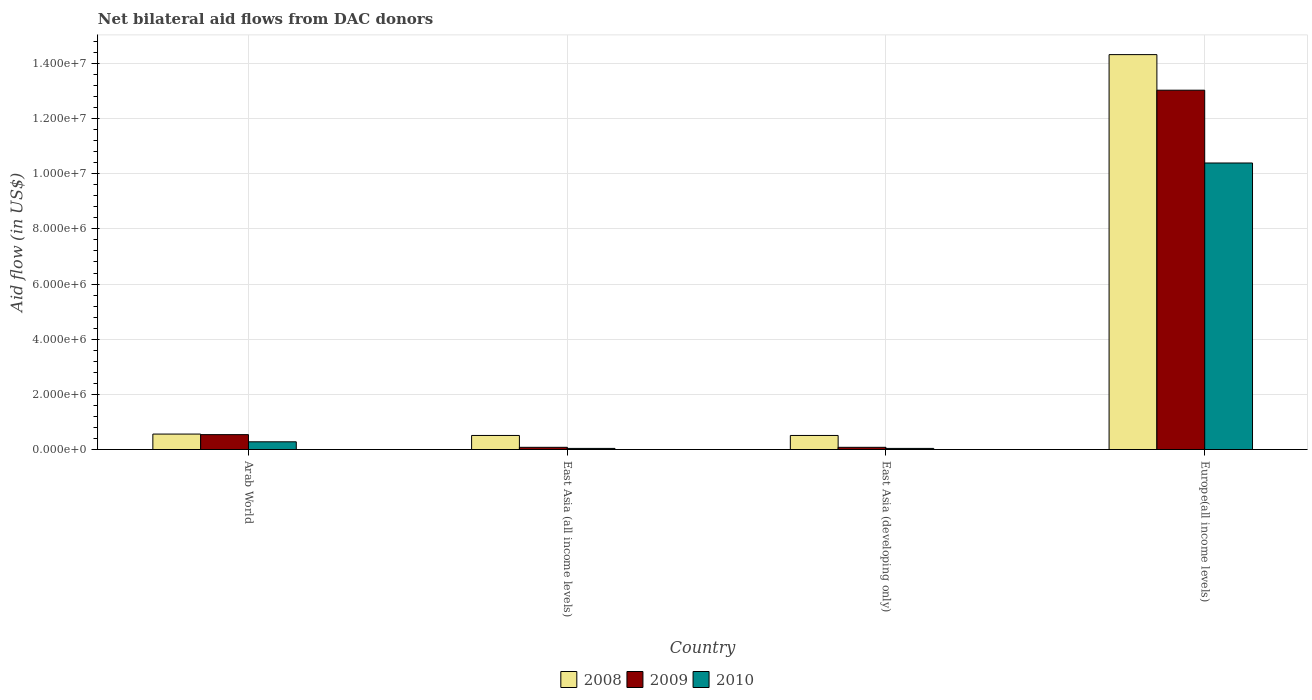How many different coloured bars are there?
Offer a terse response. 3. How many groups of bars are there?
Give a very brief answer. 4. Are the number of bars on each tick of the X-axis equal?
Your answer should be compact. Yes. How many bars are there on the 3rd tick from the left?
Give a very brief answer. 3. How many bars are there on the 3rd tick from the right?
Give a very brief answer. 3. What is the label of the 3rd group of bars from the left?
Ensure brevity in your answer.  East Asia (developing only). What is the net bilateral aid flow in 2009 in Europe(all income levels)?
Offer a terse response. 1.30e+07. Across all countries, what is the maximum net bilateral aid flow in 2009?
Give a very brief answer. 1.30e+07. Across all countries, what is the minimum net bilateral aid flow in 2009?
Provide a succinct answer. 8.00e+04. In which country was the net bilateral aid flow in 2009 maximum?
Your answer should be very brief. Europe(all income levels). In which country was the net bilateral aid flow in 2009 minimum?
Your answer should be compact. East Asia (all income levels). What is the total net bilateral aid flow in 2009 in the graph?
Provide a short and direct response. 1.37e+07. What is the difference between the net bilateral aid flow in 2010 in East Asia (all income levels) and that in Europe(all income levels)?
Give a very brief answer. -1.04e+07. What is the difference between the net bilateral aid flow in 2010 in Europe(all income levels) and the net bilateral aid flow in 2008 in East Asia (developing only)?
Your answer should be compact. 9.88e+06. What is the average net bilateral aid flow in 2010 per country?
Give a very brief answer. 2.69e+06. What is the difference between the net bilateral aid flow of/in 2008 and net bilateral aid flow of/in 2010 in Arab World?
Ensure brevity in your answer.  2.80e+05. What is the ratio of the net bilateral aid flow in 2009 in Arab World to that in Europe(all income levels)?
Give a very brief answer. 0.04. What is the difference between the highest and the second highest net bilateral aid flow in 2009?
Provide a succinct answer. 1.25e+07. What is the difference between the highest and the lowest net bilateral aid flow in 2010?
Ensure brevity in your answer.  1.04e+07. In how many countries, is the net bilateral aid flow in 2010 greater than the average net bilateral aid flow in 2010 taken over all countries?
Provide a short and direct response. 1. What does the 3rd bar from the right in Arab World represents?
Your response must be concise. 2008. Are all the bars in the graph horizontal?
Keep it short and to the point. No. What is the difference between two consecutive major ticks on the Y-axis?
Offer a terse response. 2.00e+06. Are the values on the major ticks of Y-axis written in scientific E-notation?
Make the answer very short. Yes. What is the title of the graph?
Ensure brevity in your answer.  Net bilateral aid flows from DAC donors. Does "1990" appear as one of the legend labels in the graph?
Provide a succinct answer. No. What is the label or title of the X-axis?
Make the answer very short. Country. What is the label or title of the Y-axis?
Make the answer very short. Aid flow (in US$). What is the Aid flow (in US$) of 2008 in Arab World?
Make the answer very short. 5.60e+05. What is the Aid flow (in US$) in 2009 in Arab World?
Provide a short and direct response. 5.40e+05. What is the Aid flow (in US$) in 2010 in Arab World?
Your response must be concise. 2.80e+05. What is the Aid flow (in US$) of 2008 in East Asia (all income levels)?
Make the answer very short. 5.10e+05. What is the Aid flow (in US$) of 2009 in East Asia (all income levels)?
Ensure brevity in your answer.  8.00e+04. What is the Aid flow (in US$) in 2010 in East Asia (all income levels)?
Your answer should be compact. 4.00e+04. What is the Aid flow (in US$) in 2008 in East Asia (developing only)?
Provide a short and direct response. 5.10e+05. What is the Aid flow (in US$) in 2009 in East Asia (developing only)?
Your response must be concise. 8.00e+04. What is the Aid flow (in US$) of 2010 in East Asia (developing only)?
Your answer should be compact. 4.00e+04. What is the Aid flow (in US$) in 2008 in Europe(all income levels)?
Your answer should be compact. 1.43e+07. What is the Aid flow (in US$) of 2009 in Europe(all income levels)?
Provide a succinct answer. 1.30e+07. What is the Aid flow (in US$) in 2010 in Europe(all income levels)?
Make the answer very short. 1.04e+07. Across all countries, what is the maximum Aid flow (in US$) in 2008?
Your answer should be very brief. 1.43e+07. Across all countries, what is the maximum Aid flow (in US$) of 2009?
Provide a succinct answer. 1.30e+07. Across all countries, what is the maximum Aid flow (in US$) in 2010?
Your answer should be compact. 1.04e+07. Across all countries, what is the minimum Aid flow (in US$) of 2008?
Your answer should be compact. 5.10e+05. Across all countries, what is the minimum Aid flow (in US$) in 2009?
Keep it short and to the point. 8.00e+04. What is the total Aid flow (in US$) in 2008 in the graph?
Your answer should be compact. 1.59e+07. What is the total Aid flow (in US$) of 2009 in the graph?
Your answer should be very brief. 1.37e+07. What is the total Aid flow (in US$) in 2010 in the graph?
Ensure brevity in your answer.  1.08e+07. What is the difference between the Aid flow (in US$) in 2010 in Arab World and that in East Asia (all income levels)?
Your answer should be compact. 2.40e+05. What is the difference between the Aid flow (in US$) in 2008 in Arab World and that in East Asia (developing only)?
Keep it short and to the point. 5.00e+04. What is the difference between the Aid flow (in US$) in 2009 in Arab World and that in East Asia (developing only)?
Ensure brevity in your answer.  4.60e+05. What is the difference between the Aid flow (in US$) in 2008 in Arab World and that in Europe(all income levels)?
Offer a very short reply. -1.38e+07. What is the difference between the Aid flow (in US$) of 2009 in Arab World and that in Europe(all income levels)?
Provide a short and direct response. -1.25e+07. What is the difference between the Aid flow (in US$) in 2010 in Arab World and that in Europe(all income levels)?
Give a very brief answer. -1.01e+07. What is the difference between the Aid flow (in US$) in 2008 in East Asia (all income levels) and that in Europe(all income levels)?
Your answer should be compact. -1.38e+07. What is the difference between the Aid flow (in US$) of 2009 in East Asia (all income levels) and that in Europe(all income levels)?
Your answer should be very brief. -1.30e+07. What is the difference between the Aid flow (in US$) in 2010 in East Asia (all income levels) and that in Europe(all income levels)?
Keep it short and to the point. -1.04e+07. What is the difference between the Aid flow (in US$) of 2008 in East Asia (developing only) and that in Europe(all income levels)?
Offer a terse response. -1.38e+07. What is the difference between the Aid flow (in US$) in 2009 in East Asia (developing only) and that in Europe(all income levels)?
Your answer should be compact. -1.30e+07. What is the difference between the Aid flow (in US$) in 2010 in East Asia (developing only) and that in Europe(all income levels)?
Make the answer very short. -1.04e+07. What is the difference between the Aid flow (in US$) of 2008 in Arab World and the Aid flow (in US$) of 2010 in East Asia (all income levels)?
Make the answer very short. 5.20e+05. What is the difference between the Aid flow (in US$) in 2008 in Arab World and the Aid flow (in US$) in 2009 in East Asia (developing only)?
Your answer should be very brief. 4.80e+05. What is the difference between the Aid flow (in US$) in 2008 in Arab World and the Aid flow (in US$) in 2010 in East Asia (developing only)?
Provide a short and direct response. 5.20e+05. What is the difference between the Aid flow (in US$) in 2009 in Arab World and the Aid flow (in US$) in 2010 in East Asia (developing only)?
Ensure brevity in your answer.  5.00e+05. What is the difference between the Aid flow (in US$) in 2008 in Arab World and the Aid flow (in US$) in 2009 in Europe(all income levels)?
Your answer should be very brief. -1.25e+07. What is the difference between the Aid flow (in US$) of 2008 in Arab World and the Aid flow (in US$) of 2010 in Europe(all income levels)?
Your answer should be compact. -9.83e+06. What is the difference between the Aid flow (in US$) of 2009 in Arab World and the Aid flow (in US$) of 2010 in Europe(all income levels)?
Your response must be concise. -9.85e+06. What is the difference between the Aid flow (in US$) of 2008 in East Asia (all income levels) and the Aid flow (in US$) of 2009 in East Asia (developing only)?
Give a very brief answer. 4.30e+05. What is the difference between the Aid flow (in US$) of 2008 in East Asia (all income levels) and the Aid flow (in US$) of 2009 in Europe(all income levels)?
Offer a terse response. -1.25e+07. What is the difference between the Aid flow (in US$) of 2008 in East Asia (all income levels) and the Aid flow (in US$) of 2010 in Europe(all income levels)?
Your response must be concise. -9.88e+06. What is the difference between the Aid flow (in US$) of 2009 in East Asia (all income levels) and the Aid flow (in US$) of 2010 in Europe(all income levels)?
Offer a very short reply. -1.03e+07. What is the difference between the Aid flow (in US$) in 2008 in East Asia (developing only) and the Aid flow (in US$) in 2009 in Europe(all income levels)?
Provide a succinct answer. -1.25e+07. What is the difference between the Aid flow (in US$) in 2008 in East Asia (developing only) and the Aid flow (in US$) in 2010 in Europe(all income levels)?
Ensure brevity in your answer.  -9.88e+06. What is the difference between the Aid flow (in US$) of 2009 in East Asia (developing only) and the Aid flow (in US$) of 2010 in Europe(all income levels)?
Offer a terse response. -1.03e+07. What is the average Aid flow (in US$) of 2008 per country?
Your answer should be very brief. 3.98e+06. What is the average Aid flow (in US$) in 2009 per country?
Your answer should be compact. 3.43e+06. What is the average Aid flow (in US$) in 2010 per country?
Your answer should be compact. 2.69e+06. What is the difference between the Aid flow (in US$) of 2008 and Aid flow (in US$) of 2010 in Arab World?
Your answer should be very brief. 2.80e+05. What is the difference between the Aid flow (in US$) of 2009 and Aid flow (in US$) of 2010 in East Asia (all income levels)?
Keep it short and to the point. 4.00e+04. What is the difference between the Aid flow (in US$) in 2008 and Aid flow (in US$) in 2010 in East Asia (developing only)?
Make the answer very short. 4.70e+05. What is the difference between the Aid flow (in US$) of 2008 and Aid flow (in US$) of 2009 in Europe(all income levels)?
Your response must be concise. 1.29e+06. What is the difference between the Aid flow (in US$) of 2008 and Aid flow (in US$) of 2010 in Europe(all income levels)?
Your answer should be very brief. 3.93e+06. What is the difference between the Aid flow (in US$) in 2009 and Aid flow (in US$) in 2010 in Europe(all income levels)?
Make the answer very short. 2.64e+06. What is the ratio of the Aid flow (in US$) of 2008 in Arab World to that in East Asia (all income levels)?
Give a very brief answer. 1.1. What is the ratio of the Aid flow (in US$) in 2009 in Arab World to that in East Asia (all income levels)?
Keep it short and to the point. 6.75. What is the ratio of the Aid flow (in US$) in 2008 in Arab World to that in East Asia (developing only)?
Keep it short and to the point. 1.1. What is the ratio of the Aid flow (in US$) in 2009 in Arab World to that in East Asia (developing only)?
Offer a terse response. 6.75. What is the ratio of the Aid flow (in US$) in 2008 in Arab World to that in Europe(all income levels)?
Your response must be concise. 0.04. What is the ratio of the Aid flow (in US$) of 2009 in Arab World to that in Europe(all income levels)?
Give a very brief answer. 0.04. What is the ratio of the Aid flow (in US$) of 2010 in Arab World to that in Europe(all income levels)?
Keep it short and to the point. 0.03. What is the ratio of the Aid flow (in US$) in 2010 in East Asia (all income levels) to that in East Asia (developing only)?
Provide a succinct answer. 1. What is the ratio of the Aid flow (in US$) of 2008 in East Asia (all income levels) to that in Europe(all income levels)?
Your answer should be very brief. 0.04. What is the ratio of the Aid flow (in US$) of 2009 in East Asia (all income levels) to that in Europe(all income levels)?
Offer a very short reply. 0.01. What is the ratio of the Aid flow (in US$) in 2010 in East Asia (all income levels) to that in Europe(all income levels)?
Your answer should be very brief. 0. What is the ratio of the Aid flow (in US$) of 2008 in East Asia (developing only) to that in Europe(all income levels)?
Make the answer very short. 0.04. What is the ratio of the Aid flow (in US$) in 2009 in East Asia (developing only) to that in Europe(all income levels)?
Your answer should be compact. 0.01. What is the ratio of the Aid flow (in US$) in 2010 in East Asia (developing only) to that in Europe(all income levels)?
Provide a succinct answer. 0. What is the difference between the highest and the second highest Aid flow (in US$) in 2008?
Make the answer very short. 1.38e+07. What is the difference between the highest and the second highest Aid flow (in US$) of 2009?
Provide a short and direct response. 1.25e+07. What is the difference between the highest and the second highest Aid flow (in US$) in 2010?
Offer a very short reply. 1.01e+07. What is the difference between the highest and the lowest Aid flow (in US$) of 2008?
Give a very brief answer. 1.38e+07. What is the difference between the highest and the lowest Aid flow (in US$) in 2009?
Your answer should be compact. 1.30e+07. What is the difference between the highest and the lowest Aid flow (in US$) in 2010?
Provide a succinct answer. 1.04e+07. 